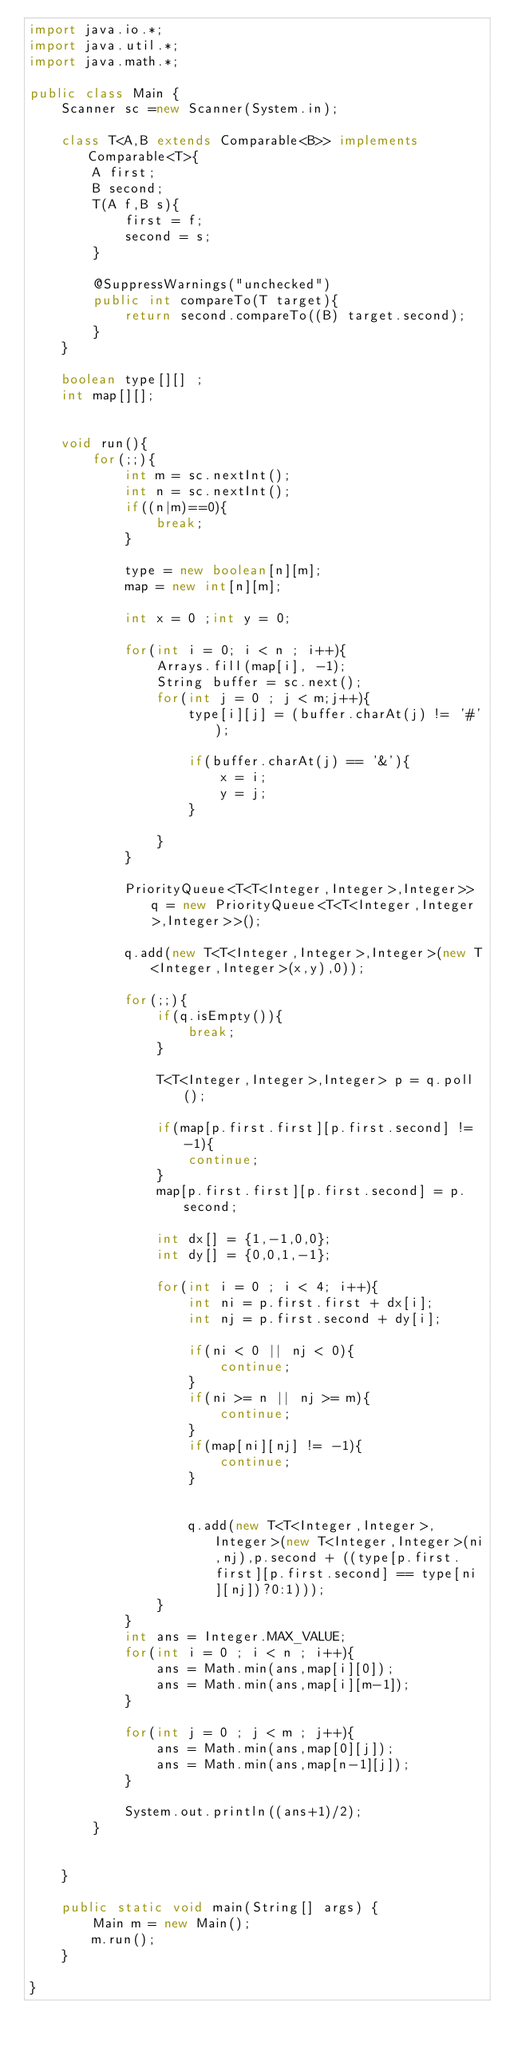Convert code to text. <code><loc_0><loc_0><loc_500><loc_500><_Java_>import java.io.*;
import java.util.*;
import java.math.*;

public class Main {
	Scanner sc =new Scanner(System.in);
	
	class T<A,B extends Comparable<B>> implements Comparable<T>{
		A first;
		B second;
		T(A f,B s){
			first = f;
			second = s;
		}
		
		@SuppressWarnings("unchecked")
		public int compareTo(T target){
			return second.compareTo((B) target.second);
		}
	}
	
	boolean type[][] ;
	int map[][];
	

	void run(){
		for(;;){
			int m = sc.nextInt();
			int n = sc.nextInt();
			if((n|m)==0){
				break;
			}
			
			type = new boolean[n][m];
			map = new int[n][m];
			
			int x = 0 ;int y = 0;
			
			for(int i = 0; i < n ; i++){
				Arrays.fill(map[i], -1);
				String buffer = sc.next();
				for(int j = 0 ; j < m;j++){
					type[i][j] = (buffer.charAt(j) != '#');

					if(buffer.charAt(j) == '&'){
						x = i;
						y = j;
					}
					
				}
			}
			
			PriorityQueue<T<T<Integer,Integer>,Integer>> q = new PriorityQueue<T<T<Integer,Integer>,Integer>>();
			
			q.add(new T<T<Integer,Integer>,Integer>(new T<Integer,Integer>(x,y),0));
			
			for(;;){
				if(q.isEmpty()){
					break;
				}
				
				T<T<Integer,Integer>,Integer> p = q.poll();
				
				if(map[p.first.first][p.first.second] != -1){
					continue;
				}
				map[p.first.first][p.first.second] = p.second;
				
				int dx[] = {1,-1,0,0};
				int dy[] = {0,0,1,-1};
				
				for(int i = 0 ; i < 4; i++){
					int ni = p.first.first + dx[i];
					int nj = p.first.second + dy[i];
					
					if(ni < 0 || nj < 0){
						continue;
					}
					if(ni >= n || nj >= m){
						continue;
					}
					if(map[ni][nj] != -1){
						continue;
					}
					

					q.add(new T<T<Integer,Integer>,Integer>(new T<Integer,Integer>(ni,nj),p.second + ((type[p.first.first][p.first.second] == type[ni][nj])?0:1)));
				}
			}
			int ans = Integer.MAX_VALUE;
			for(int i = 0 ; i < n ; i++){
				ans = Math.min(ans,map[i][0]);
				ans = Math.min(ans,map[i][m-1]);
			}

			for(int j = 0 ; j < m ; j++){
				ans = Math.min(ans,map[0][j]);
				ans = Math.min(ans,map[n-1][j]);
			}

			System.out.println((ans+1)/2);
		}
		
		
	}
	
	public static void main(String[] args) {
		Main m = new Main();
		m.run();
	}

}</code> 